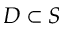<formula> <loc_0><loc_0><loc_500><loc_500>D \subset S</formula> 